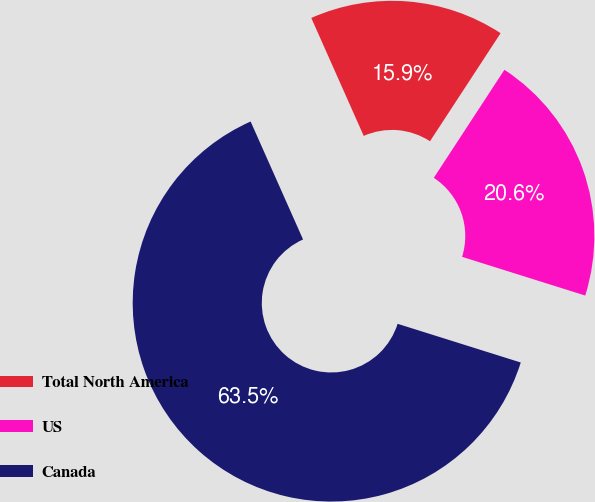Convert chart. <chart><loc_0><loc_0><loc_500><loc_500><pie_chart><fcel>Total North America<fcel>US<fcel>Canada<nl><fcel>15.87%<fcel>20.63%<fcel>63.49%<nl></chart> 